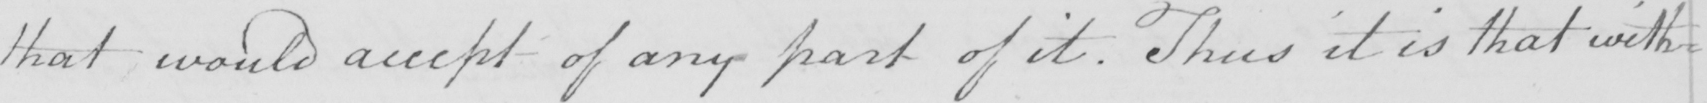What text is written in this handwritten line? that would accept of any part of it . Thus it is that with= 